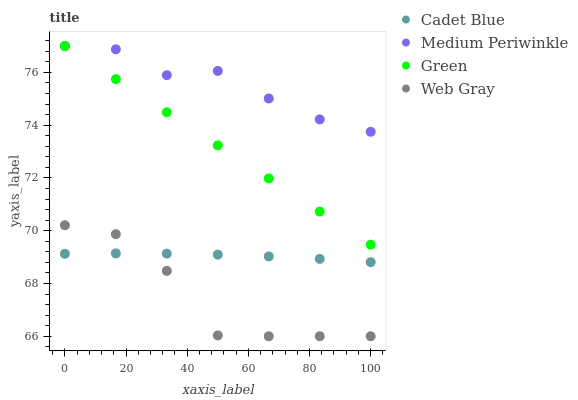Does Web Gray have the minimum area under the curve?
Answer yes or no. Yes. Does Medium Periwinkle have the maximum area under the curve?
Answer yes or no. Yes. Does Green have the minimum area under the curve?
Answer yes or no. No. Does Green have the maximum area under the curve?
Answer yes or no. No. Is Green the smoothest?
Answer yes or no. Yes. Is Web Gray the roughest?
Answer yes or no. Yes. Is Cadet Blue the smoothest?
Answer yes or no. No. Is Cadet Blue the roughest?
Answer yes or no. No. Does Web Gray have the lowest value?
Answer yes or no. Yes. Does Green have the lowest value?
Answer yes or no. No. Does Medium Periwinkle have the highest value?
Answer yes or no. Yes. Does Cadet Blue have the highest value?
Answer yes or no. No. Is Web Gray less than Green?
Answer yes or no. Yes. Is Green greater than Web Gray?
Answer yes or no. Yes. Does Medium Periwinkle intersect Green?
Answer yes or no. Yes. Is Medium Periwinkle less than Green?
Answer yes or no. No. Is Medium Periwinkle greater than Green?
Answer yes or no. No. Does Web Gray intersect Green?
Answer yes or no. No. 